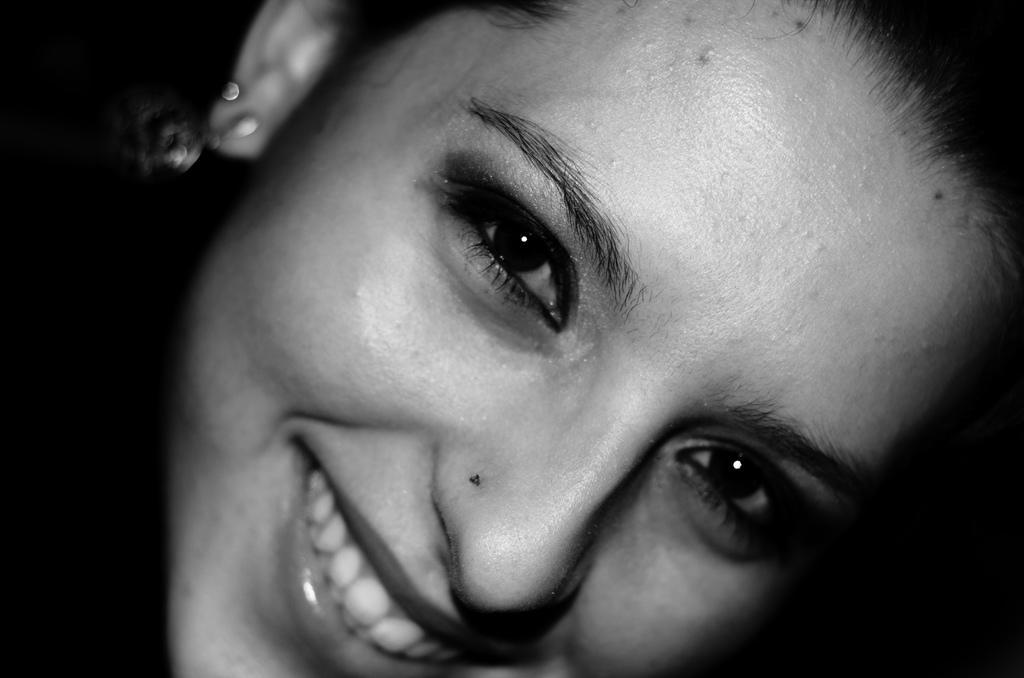Could you give a brief overview of what you see in this image? In this image I can see the person's face and I can see the person is smiling. And there is a black background. 